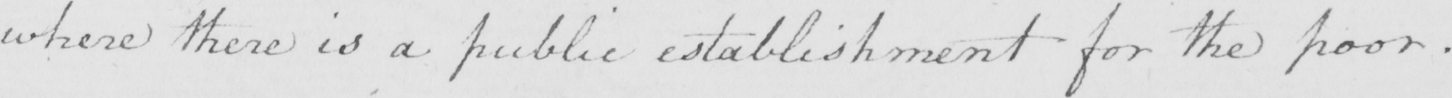What does this handwritten line say? where there is a public establishment for the poor . 